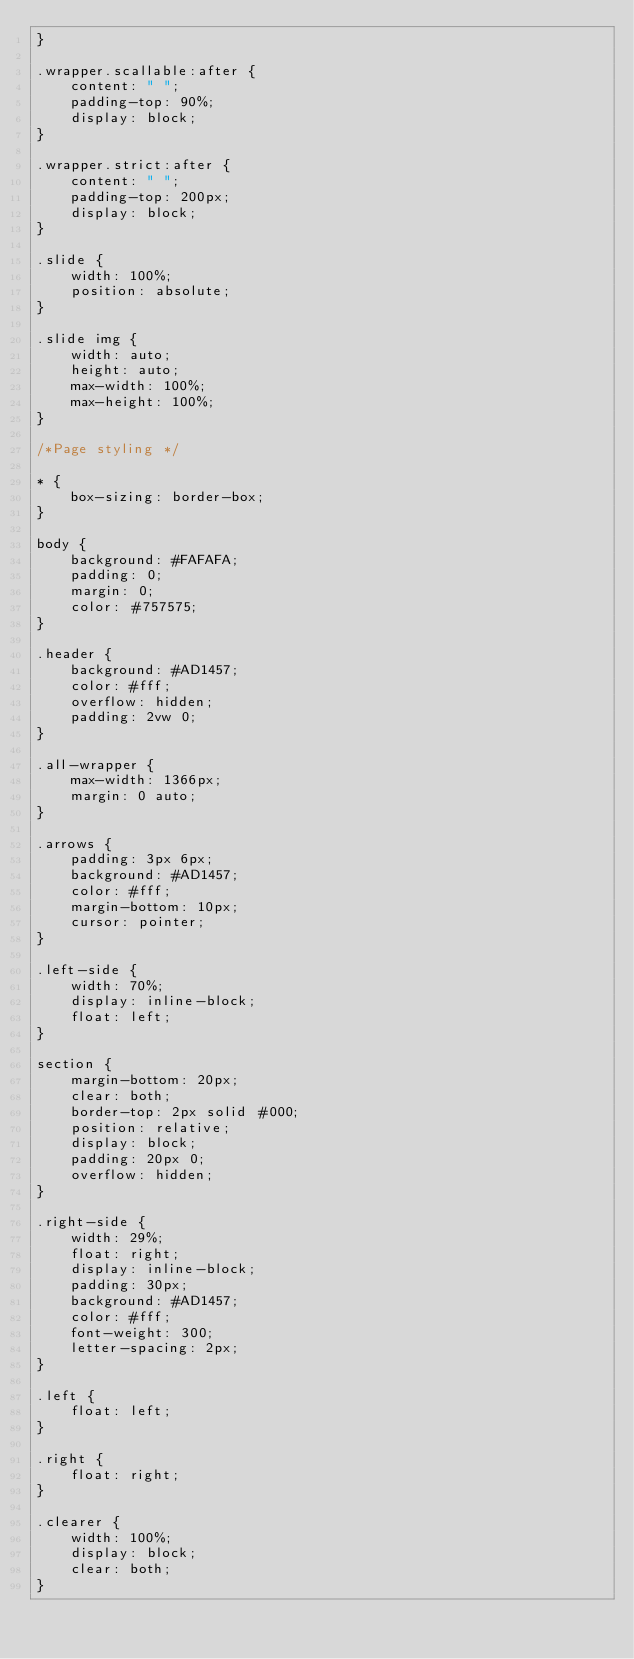Convert code to text. <code><loc_0><loc_0><loc_500><loc_500><_CSS_>}

.wrapper.scallable:after {
    content: " ";
    padding-top: 90%;
    display: block;
}

.wrapper.strict:after {
    content: " ";
    padding-top: 200px;
    display: block;
}

.slide {
    width: 100%;
    position: absolute;
}

.slide img {
    width: auto;
    height: auto;
    max-width: 100%;
    max-height: 100%;
}

/*Page styling */

* {
    box-sizing: border-box;
}

body {
    background: #FAFAFA;
    padding: 0;
    margin: 0;
    color: #757575;
}

.header {
    background: #AD1457;
    color: #fff;
    overflow: hidden;
    padding: 2vw 0;
}

.all-wrapper {
    max-width: 1366px;
    margin: 0 auto;
}

.arrows {
    padding: 3px 6px;
    background: #AD1457;
    color: #fff;
    margin-bottom: 10px;
    cursor: pointer;
}

.left-side {
    width: 70%;
    display: inline-block;
    float: left;
}

section {
    margin-bottom: 20px;
    clear: both;
    border-top: 2px solid #000;
    position: relative;
    display: block;
    padding: 20px 0;
    overflow: hidden;
}

.right-side {
    width: 29%;
    float: right;
    display: inline-block;
    padding: 30px;
    background: #AD1457;
    color: #fff;
    font-weight: 300;
    letter-spacing: 2px;
}

.left {
    float: left;
}

.right {
    float: right;
}

.clearer {
    width: 100%;
    display: block;
    clear: both;
}</code> 